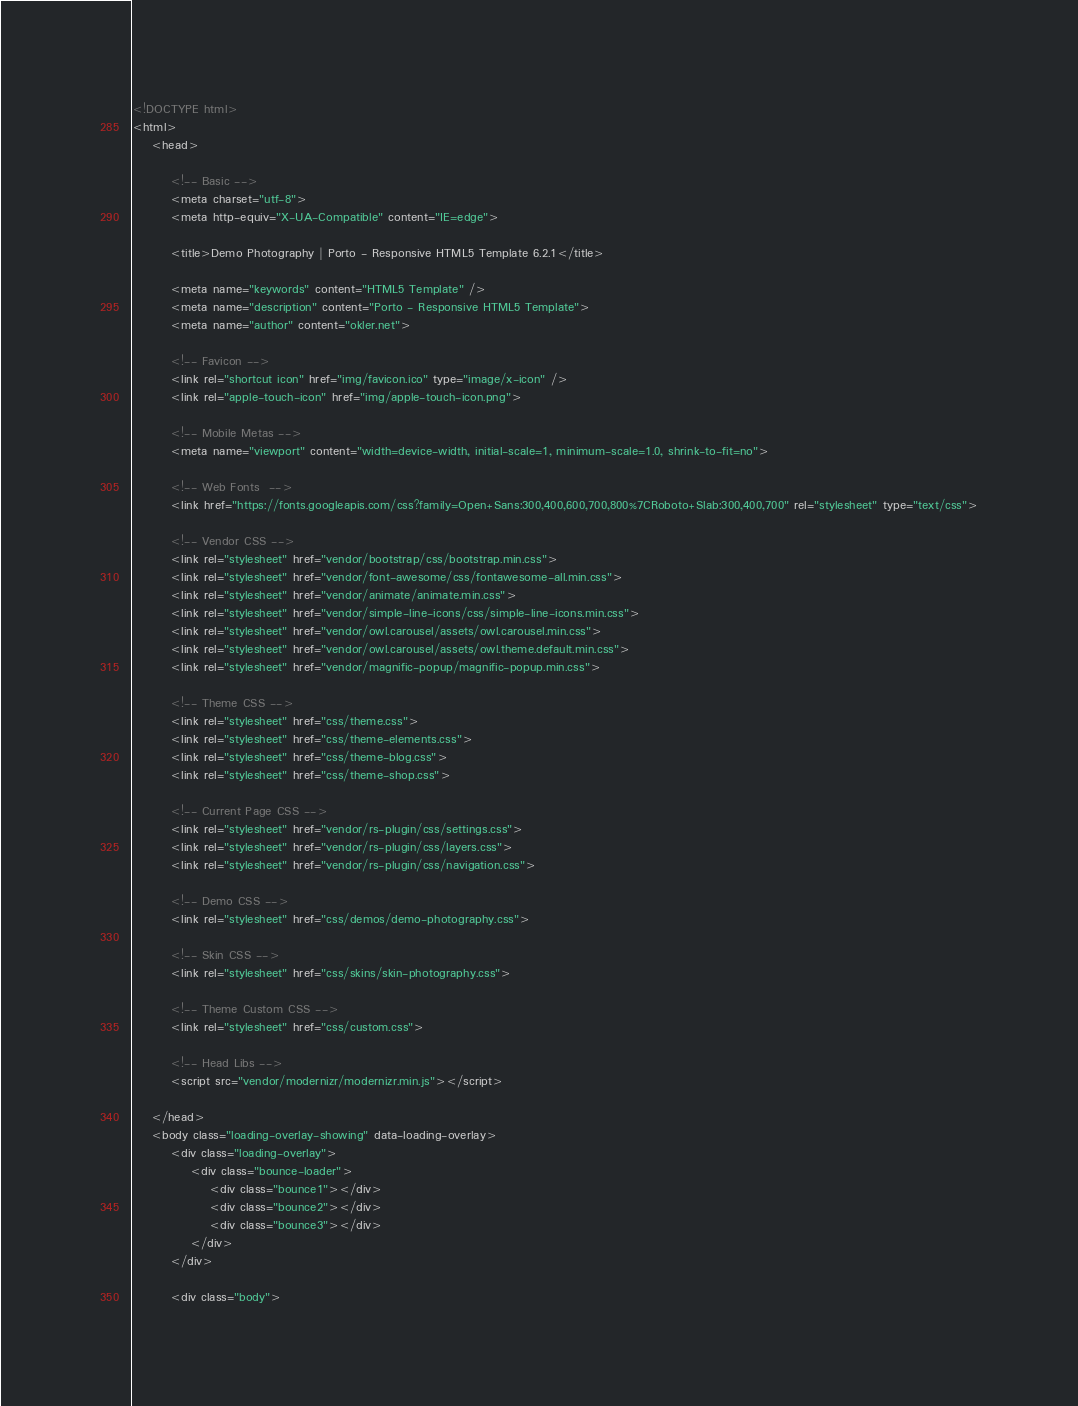Convert code to text. <code><loc_0><loc_0><loc_500><loc_500><_HTML_><!DOCTYPE html>
<html>
	<head>

		<!-- Basic -->
		<meta charset="utf-8">
		<meta http-equiv="X-UA-Compatible" content="IE=edge">	

		<title>Demo Photography | Porto - Responsive HTML5 Template 6.2.1</title>	

		<meta name="keywords" content="HTML5 Template" />
		<meta name="description" content="Porto - Responsive HTML5 Template">
		<meta name="author" content="okler.net">

		<!-- Favicon -->
		<link rel="shortcut icon" href="img/favicon.ico" type="image/x-icon" />
		<link rel="apple-touch-icon" href="img/apple-touch-icon.png">

		<!-- Mobile Metas -->
		<meta name="viewport" content="width=device-width, initial-scale=1, minimum-scale=1.0, shrink-to-fit=no">

		<!-- Web Fonts  -->
		<link href="https://fonts.googleapis.com/css?family=Open+Sans:300,400,600,700,800%7CRoboto+Slab:300,400,700" rel="stylesheet" type="text/css">

		<!-- Vendor CSS -->
		<link rel="stylesheet" href="vendor/bootstrap/css/bootstrap.min.css">
		<link rel="stylesheet" href="vendor/font-awesome/css/fontawesome-all.min.css">
		<link rel="stylesheet" href="vendor/animate/animate.min.css">
		<link rel="stylesheet" href="vendor/simple-line-icons/css/simple-line-icons.min.css">
		<link rel="stylesheet" href="vendor/owl.carousel/assets/owl.carousel.min.css">
		<link rel="stylesheet" href="vendor/owl.carousel/assets/owl.theme.default.min.css">
		<link rel="stylesheet" href="vendor/magnific-popup/magnific-popup.min.css">

		<!-- Theme CSS -->
		<link rel="stylesheet" href="css/theme.css">
		<link rel="stylesheet" href="css/theme-elements.css">
		<link rel="stylesheet" href="css/theme-blog.css">
		<link rel="stylesheet" href="css/theme-shop.css">

		<!-- Current Page CSS -->
		<link rel="stylesheet" href="vendor/rs-plugin/css/settings.css">
		<link rel="stylesheet" href="vendor/rs-plugin/css/layers.css">
		<link rel="stylesheet" href="vendor/rs-plugin/css/navigation.css">
		
		<!-- Demo CSS -->
		<link rel="stylesheet" href="css/demos/demo-photography.css">

		<!-- Skin CSS -->
		<link rel="stylesheet" href="css/skins/skin-photography.css"> 

		<!-- Theme Custom CSS -->
		<link rel="stylesheet" href="css/custom.css">

		<!-- Head Libs -->
		<script src="vendor/modernizr/modernizr.min.js"></script>

	</head>
	<body class="loading-overlay-showing" data-loading-overlay>
		<div class="loading-overlay">
			<div class="bounce-loader">
				<div class="bounce1"></div>
				<div class="bounce2"></div>
				<div class="bounce3"></div>
			</div>
		</div>

		<div class="body"></code> 